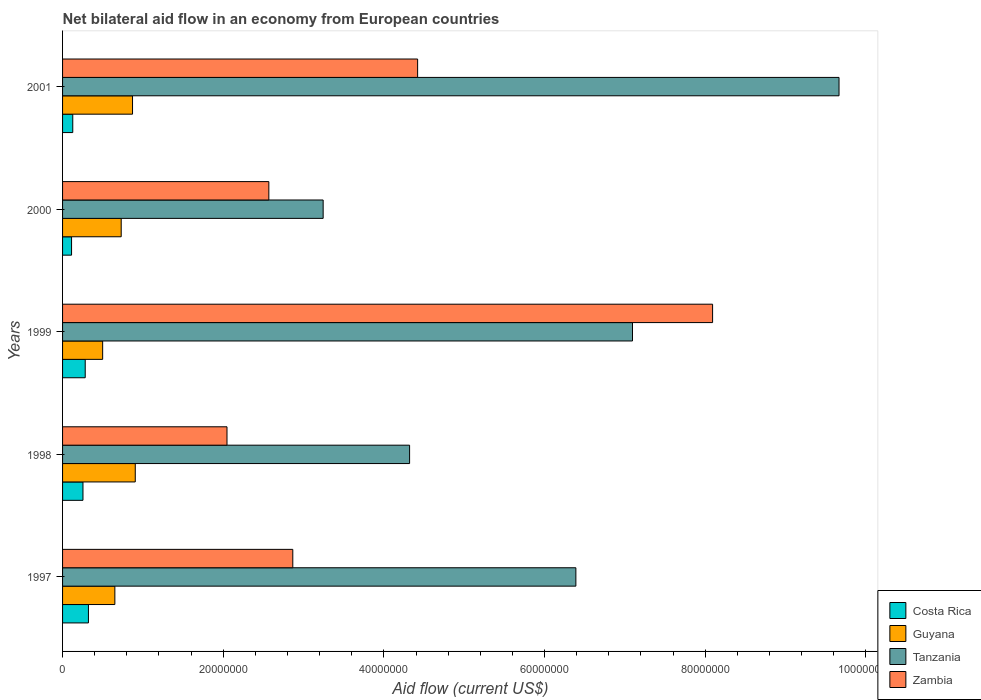How many groups of bars are there?
Offer a terse response. 5. Are the number of bars per tick equal to the number of legend labels?
Provide a short and direct response. Yes. Are the number of bars on each tick of the Y-axis equal?
Keep it short and to the point. Yes. How many bars are there on the 5th tick from the top?
Your answer should be very brief. 4. What is the label of the 1st group of bars from the top?
Provide a short and direct response. 2001. In how many cases, is the number of bars for a given year not equal to the number of legend labels?
Provide a succinct answer. 0. What is the net bilateral aid flow in Costa Rica in 1998?
Provide a short and direct response. 2.54e+06. Across all years, what is the maximum net bilateral aid flow in Guyana?
Give a very brief answer. 9.05e+06. Across all years, what is the minimum net bilateral aid flow in Tanzania?
Give a very brief answer. 3.24e+07. In which year was the net bilateral aid flow in Tanzania maximum?
Offer a very short reply. 2001. In which year was the net bilateral aid flow in Tanzania minimum?
Offer a terse response. 2000. What is the total net bilateral aid flow in Tanzania in the graph?
Keep it short and to the point. 3.07e+08. What is the difference between the net bilateral aid flow in Guyana in 1999 and that in 2000?
Provide a succinct answer. -2.31e+06. What is the difference between the net bilateral aid flow in Zambia in 1998 and the net bilateral aid flow in Costa Rica in 1997?
Your answer should be very brief. 1.72e+07. What is the average net bilateral aid flow in Guyana per year?
Give a very brief answer. 7.31e+06. In the year 2000, what is the difference between the net bilateral aid flow in Zambia and net bilateral aid flow in Costa Rica?
Provide a short and direct response. 2.46e+07. What is the ratio of the net bilateral aid flow in Tanzania in 1999 to that in 2000?
Provide a short and direct response. 2.19. Is the net bilateral aid flow in Zambia in 1999 less than that in 2000?
Ensure brevity in your answer.  No. What is the difference between the highest and the second highest net bilateral aid flow in Costa Rica?
Make the answer very short. 4.00e+05. What is the difference between the highest and the lowest net bilateral aid flow in Tanzania?
Provide a succinct answer. 6.42e+07. Is the sum of the net bilateral aid flow in Tanzania in 1999 and 2001 greater than the maximum net bilateral aid flow in Costa Rica across all years?
Your response must be concise. Yes. Is it the case that in every year, the sum of the net bilateral aid flow in Costa Rica and net bilateral aid flow in Tanzania is greater than the sum of net bilateral aid flow in Guyana and net bilateral aid flow in Zambia?
Provide a succinct answer. Yes. What does the 4th bar from the top in 1998 represents?
Your response must be concise. Costa Rica. What does the 4th bar from the bottom in 2001 represents?
Provide a succinct answer. Zambia. Are all the bars in the graph horizontal?
Ensure brevity in your answer.  Yes. What is the difference between two consecutive major ticks on the X-axis?
Give a very brief answer. 2.00e+07. Does the graph contain any zero values?
Make the answer very short. No. Where does the legend appear in the graph?
Provide a short and direct response. Bottom right. How are the legend labels stacked?
Your response must be concise. Vertical. What is the title of the graph?
Keep it short and to the point. Net bilateral aid flow in an economy from European countries. What is the Aid flow (current US$) in Costa Rica in 1997?
Provide a succinct answer. 3.22e+06. What is the Aid flow (current US$) in Guyana in 1997?
Give a very brief answer. 6.51e+06. What is the Aid flow (current US$) of Tanzania in 1997?
Give a very brief answer. 6.39e+07. What is the Aid flow (current US$) of Zambia in 1997?
Provide a succinct answer. 2.87e+07. What is the Aid flow (current US$) in Costa Rica in 1998?
Your response must be concise. 2.54e+06. What is the Aid flow (current US$) in Guyana in 1998?
Your response must be concise. 9.05e+06. What is the Aid flow (current US$) in Tanzania in 1998?
Give a very brief answer. 4.32e+07. What is the Aid flow (current US$) of Zambia in 1998?
Your answer should be very brief. 2.05e+07. What is the Aid flow (current US$) in Costa Rica in 1999?
Offer a very short reply. 2.82e+06. What is the Aid flow (current US$) of Guyana in 1999?
Provide a succinct answer. 4.99e+06. What is the Aid flow (current US$) in Tanzania in 1999?
Your response must be concise. 7.10e+07. What is the Aid flow (current US$) in Zambia in 1999?
Offer a terse response. 8.09e+07. What is the Aid flow (current US$) in Costa Rica in 2000?
Your answer should be compact. 1.12e+06. What is the Aid flow (current US$) of Guyana in 2000?
Your response must be concise. 7.30e+06. What is the Aid flow (current US$) of Tanzania in 2000?
Offer a terse response. 3.24e+07. What is the Aid flow (current US$) of Zambia in 2000?
Make the answer very short. 2.57e+07. What is the Aid flow (current US$) in Costa Rica in 2001?
Offer a terse response. 1.27e+06. What is the Aid flow (current US$) in Guyana in 2001?
Provide a succinct answer. 8.71e+06. What is the Aid flow (current US$) of Tanzania in 2001?
Offer a terse response. 9.67e+07. What is the Aid flow (current US$) of Zambia in 2001?
Your answer should be very brief. 4.42e+07. Across all years, what is the maximum Aid flow (current US$) in Costa Rica?
Offer a very short reply. 3.22e+06. Across all years, what is the maximum Aid flow (current US$) in Guyana?
Ensure brevity in your answer.  9.05e+06. Across all years, what is the maximum Aid flow (current US$) of Tanzania?
Ensure brevity in your answer.  9.67e+07. Across all years, what is the maximum Aid flow (current US$) in Zambia?
Provide a succinct answer. 8.09e+07. Across all years, what is the minimum Aid flow (current US$) in Costa Rica?
Offer a terse response. 1.12e+06. Across all years, what is the minimum Aid flow (current US$) in Guyana?
Provide a succinct answer. 4.99e+06. Across all years, what is the minimum Aid flow (current US$) of Tanzania?
Provide a succinct answer. 3.24e+07. Across all years, what is the minimum Aid flow (current US$) of Zambia?
Offer a terse response. 2.05e+07. What is the total Aid flow (current US$) in Costa Rica in the graph?
Give a very brief answer. 1.10e+07. What is the total Aid flow (current US$) in Guyana in the graph?
Offer a terse response. 3.66e+07. What is the total Aid flow (current US$) in Tanzania in the graph?
Make the answer very short. 3.07e+08. What is the total Aid flow (current US$) in Zambia in the graph?
Give a very brief answer. 2.00e+08. What is the difference between the Aid flow (current US$) of Costa Rica in 1997 and that in 1998?
Your answer should be compact. 6.80e+05. What is the difference between the Aid flow (current US$) of Guyana in 1997 and that in 1998?
Give a very brief answer. -2.54e+06. What is the difference between the Aid flow (current US$) in Tanzania in 1997 and that in 1998?
Provide a short and direct response. 2.07e+07. What is the difference between the Aid flow (current US$) of Zambia in 1997 and that in 1998?
Your answer should be very brief. 8.19e+06. What is the difference between the Aid flow (current US$) of Guyana in 1997 and that in 1999?
Your answer should be compact. 1.52e+06. What is the difference between the Aid flow (current US$) in Tanzania in 1997 and that in 1999?
Ensure brevity in your answer.  -7.05e+06. What is the difference between the Aid flow (current US$) in Zambia in 1997 and that in 1999?
Make the answer very short. -5.23e+07. What is the difference between the Aid flow (current US$) of Costa Rica in 1997 and that in 2000?
Ensure brevity in your answer.  2.10e+06. What is the difference between the Aid flow (current US$) of Guyana in 1997 and that in 2000?
Keep it short and to the point. -7.90e+05. What is the difference between the Aid flow (current US$) of Tanzania in 1997 and that in 2000?
Offer a terse response. 3.15e+07. What is the difference between the Aid flow (current US$) of Zambia in 1997 and that in 2000?
Make the answer very short. 2.98e+06. What is the difference between the Aid flow (current US$) of Costa Rica in 1997 and that in 2001?
Ensure brevity in your answer.  1.95e+06. What is the difference between the Aid flow (current US$) in Guyana in 1997 and that in 2001?
Your answer should be compact. -2.20e+06. What is the difference between the Aid flow (current US$) of Tanzania in 1997 and that in 2001?
Offer a very short reply. -3.28e+07. What is the difference between the Aid flow (current US$) of Zambia in 1997 and that in 2001?
Your response must be concise. -1.55e+07. What is the difference between the Aid flow (current US$) in Costa Rica in 1998 and that in 1999?
Keep it short and to the point. -2.80e+05. What is the difference between the Aid flow (current US$) of Guyana in 1998 and that in 1999?
Keep it short and to the point. 4.06e+06. What is the difference between the Aid flow (current US$) in Tanzania in 1998 and that in 1999?
Provide a short and direct response. -2.78e+07. What is the difference between the Aid flow (current US$) in Zambia in 1998 and that in 1999?
Make the answer very short. -6.04e+07. What is the difference between the Aid flow (current US$) of Costa Rica in 1998 and that in 2000?
Make the answer very short. 1.42e+06. What is the difference between the Aid flow (current US$) of Guyana in 1998 and that in 2000?
Your answer should be very brief. 1.75e+06. What is the difference between the Aid flow (current US$) of Tanzania in 1998 and that in 2000?
Offer a very short reply. 1.08e+07. What is the difference between the Aid flow (current US$) of Zambia in 1998 and that in 2000?
Ensure brevity in your answer.  -5.21e+06. What is the difference between the Aid flow (current US$) of Costa Rica in 1998 and that in 2001?
Provide a succinct answer. 1.27e+06. What is the difference between the Aid flow (current US$) in Guyana in 1998 and that in 2001?
Offer a very short reply. 3.40e+05. What is the difference between the Aid flow (current US$) in Tanzania in 1998 and that in 2001?
Give a very brief answer. -5.35e+07. What is the difference between the Aid flow (current US$) in Zambia in 1998 and that in 2001?
Your response must be concise. -2.37e+07. What is the difference between the Aid flow (current US$) in Costa Rica in 1999 and that in 2000?
Provide a succinct answer. 1.70e+06. What is the difference between the Aid flow (current US$) of Guyana in 1999 and that in 2000?
Your answer should be compact. -2.31e+06. What is the difference between the Aid flow (current US$) of Tanzania in 1999 and that in 2000?
Your response must be concise. 3.85e+07. What is the difference between the Aid flow (current US$) of Zambia in 1999 and that in 2000?
Your answer should be very brief. 5.52e+07. What is the difference between the Aid flow (current US$) of Costa Rica in 1999 and that in 2001?
Offer a terse response. 1.55e+06. What is the difference between the Aid flow (current US$) in Guyana in 1999 and that in 2001?
Offer a very short reply. -3.72e+06. What is the difference between the Aid flow (current US$) in Tanzania in 1999 and that in 2001?
Your response must be concise. -2.57e+07. What is the difference between the Aid flow (current US$) in Zambia in 1999 and that in 2001?
Provide a short and direct response. 3.67e+07. What is the difference between the Aid flow (current US$) in Costa Rica in 2000 and that in 2001?
Provide a short and direct response. -1.50e+05. What is the difference between the Aid flow (current US$) of Guyana in 2000 and that in 2001?
Give a very brief answer. -1.41e+06. What is the difference between the Aid flow (current US$) in Tanzania in 2000 and that in 2001?
Provide a succinct answer. -6.42e+07. What is the difference between the Aid flow (current US$) in Zambia in 2000 and that in 2001?
Give a very brief answer. -1.85e+07. What is the difference between the Aid flow (current US$) in Costa Rica in 1997 and the Aid flow (current US$) in Guyana in 1998?
Make the answer very short. -5.83e+06. What is the difference between the Aid flow (current US$) in Costa Rica in 1997 and the Aid flow (current US$) in Tanzania in 1998?
Your response must be concise. -4.00e+07. What is the difference between the Aid flow (current US$) in Costa Rica in 1997 and the Aid flow (current US$) in Zambia in 1998?
Your answer should be very brief. -1.72e+07. What is the difference between the Aid flow (current US$) in Guyana in 1997 and the Aid flow (current US$) in Tanzania in 1998?
Ensure brevity in your answer.  -3.67e+07. What is the difference between the Aid flow (current US$) in Guyana in 1997 and the Aid flow (current US$) in Zambia in 1998?
Make the answer very short. -1.40e+07. What is the difference between the Aid flow (current US$) of Tanzania in 1997 and the Aid flow (current US$) of Zambia in 1998?
Your response must be concise. 4.34e+07. What is the difference between the Aid flow (current US$) in Costa Rica in 1997 and the Aid flow (current US$) in Guyana in 1999?
Provide a short and direct response. -1.77e+06. What is the difference between the Aid flow (current US$) of Costa Rica in 1997 and the Aid flow (current US$) of Tanzania in 1999?
Make the answer very short. -6.77e+07. What is the difference between the Aid flow (current US$) in Costa Rica in 1997 and the Aid flow (current US$) in Zambia in 1999?
Your response must be concise. -7.77e+07. What is the difference between the Aid flow (current US$) in Guyana in 1997 and the Aid flow (current US$) in Tanzania in 1999?
Offer a terse response. -6.44e+07. What is the difference between the Aid flow (current US$) of Guyana in 1997 and the Aid flow (current US$) of Zambia in 1999?
Offer a terse response. -7.44e+07. What is the difference between the Aid flow (current US$) in Tanzania in 1997 and the Aid flow (current US$) in Zambia in 1999?
Provide a succinct answer. -1.70e+07. What is the difference between the Aid flow (current US$) in Costa Rica in 1997 and the Aid flow (current US$) in Guyana in 2000?
Your answer should be very brief. -4.08e+06. What is the difference between the Aid flow (current US$) in Costa Rica in 1997 and the Aid flow (current US$) in Tanzania in 2000?
Your response must be concise. -2.92e+07. What is the difference between the Aid flow (current US$) of Costa Rica in 1997 and the Aid flow (current US$) of Zambia in 2000?
Offer a very short reply. -2.25e+07. What is the difference between the Aid flow (current US$) in Guyana in 1997 and the Aid flow (current US$) in Tanzania in 2000?
Offer a very short reply. -2.59e+07. What is the difference between the Aid flow (current US$) in Guyana in 1997 and the Aid flow (current US$) in Zambia in 2000?
Keep it short and to the point. -1.92e+07. What is the difference between the Aid flow (current US$) of Tanzania in 1997 and the Aid flow (current US$) of Zambia in 2000?
Ensure brevity in your answer.  3.82e+07. What is the difference between the Aid flow (current US$) in Costa Rica in 1997 and the Aid flow (current US$) in Guyana in 2001?
Offer a very short reply. -5.49e+06. What is the difference between the Aid flow (current US$) in Costa Rica in 1997 and the Aid flow (current US$) in Tanzania in 2001?
Give a very brief answer. -9.34e+07. What is the difference between the Aid flow (current US$) of Costa Rica in 1997 and the Aid flow (current US$) of Zambia in 2001?
Provide a succinct answer. -4.10e+07. What is the difference between the Aid flow (current US$) in Guyana in 1997 and the Aid flow (current US$) in Tanzania in 2001?
Keep it short and to the point. -9.02e+07. What is the difference between the Aid flow (current US$) of Guyana in 1997 and the Aid flow (current US$) of Zambia in 2001?
Your response must be concise. -3.77e+07. What is the difference between the Aid flow (current US$) in Tanzania in 1997 and the Aid flow (current US$) in Zambia in 2001?
Your answer should be compact. 1.97e+07. What is the difference between the Aid flow (current US$) of Costa Rica in 1998 and the Aid flow (current US$) of Guyana in 1999?
Provide a succinct answer. -2.45e+06. What is the difference between the Aid flow (current US$) in Costa Rica in 1998 and the Aid flow (current US$) in Tanzania in 1999?
Provide a succinct answer. -6.84e+07. What is the difference between the Aid flow (current US$) of Costa Rica in 1998 and the Aid flow (current US$) of Zambia in 1999?
Make the answer very short. -7.84e+07. What is the difference between the Aid flow (current US$) in Guyana in 1998 and the Aid flow (current US$) in Tanzania in 1999?
Give a very brief answer. -6.19e+07. What is the difference between the Aid flow (current US$) of Guyana in 1998 and the Aid flow (current US$) of Zambia in 1999?
Make the answer very short. -7.19e+07. What is the difference between the Aid flow (current US$) in Tanzania in 1998 and the Aid flow (current US$) in Zambia in 1999?
Your answer should be very brief. -3.77e+07. What is the difference between the Aid flow (current US$) in Costa Rica in 1998 and the Aid flow (current US$) in Guyana in 2000?
Offer a very short reply. -4.76e+06. What is the difference between the Aid flow (current US$) of Costa Rica in 1998 and the Aid flow (current US$) of Tanzania in 2000?
Provide a succinct answer. -2.99e+07. What is the difference between the Aid flow (current US$) in Costa Rica in 1998 and the Aid flow (current US$) in Zambia in 2000?
Your answer should be compact. -2.31e+07. What is the difference between the Aid flow (current US$) in Guyana in 1998 and the Aid flow (current US$) in Tanzania in 2000?
Your response must be concise. -2.34e+07. What is the difference between the Aid flow (current US$) of Guyana in 1998 and the Aid flow (current US$) of Zambia in 2000?
Offer a very short reply. -1.66e+07. What is the difference between the Aid flow (current US$) in Tanzania in 1998 and the Aid flow (current US$) in Zambia in 2000?
Provide a succinct answer. 1.75e+07. What is the difference between the Aid flow (current US$) of Costa Rica in 1998 and the Aid flow (current US$) of Guyana in 2001?
Your answer should be very brief. -6.17e+06. What is the difference between the Aid flow (current US$) of Costa Rica in 1998 and the Aid flow (current US$) of Tanzania in 2001?
Offer a terse response. -9.41e+07. What is the difference between the Aid flow (current US$) in Costa Rica in 1998 and the Aid flow (current US$) in Zambia in 2001?
Your answer should be very brief. -4.17e+07. What is the difference between the Aid flow (current US$) in Guyana in 1998 and the Aid flow (current US$) in Tanzania in 2001?
Give a very brief answer. -8.76e+07. What is the difference between the Aid flow (current US$) in Guyana in 1998 and the Aid flow (current US$) in Zambia in 2001?
Offer a terse response. -3.52e+07. What is the difference between the Aid flow (current US$) of Tanzania in 1998 and the Aid flow (current US$) of Zambia in 2001?
Provide a succinct answer. -1.00e+06. What is the difference between the Aid flow (current US$) of Costa Rica in 1999 and the Aid flow (current US$) of Guyana in 2000?
Keep it short and to the point. -4.48e+06. What is the difference between the Aid flow (current US$) of Costa Rica in 1999 and the Aid flow (current US$) of Tanzania in 2000?
Ensure brevity in your answer.  -2.96e+07. What is the difference between the Aid flow (current US$) in Costa Rica in 1999 and the Aid flow (current US$) in Zambia in 2000?
Provide a succinct answer. -2.29e+07. What is the difference between the Aid flow (current US$) in Guyana in 1999 and the Aid flow (current US$) in Tanzania in 2000?
Make the answer very short. -2.74e+07. What is the difference between the Aid flow (current US$) in Guyana in 1999 and the Aid flow (current US$) in Zambia in 2000?
Offer a terse response. -2.07e+07. What is the difference between the Aid flow (current US$) of Tanzania in 1999 and the Aid flow (current US$) of Zambia in 2000?
Offer a terse response. 4.53e+07. What is the difference between the Aid flow (current US$) of Costa Rica in 1999 and the Aid flow (current US$) of Guyana in 2001?
Your answer should be compact. -5.89e+06. What is the difference between the Aid flow (current US$) of Costa Rica in 1999 and the Aid flow (current US$) of Tanzania in 2001?
Offer a terse response. -9.38e+07. What is the difference between the Aid flow (current US$) of Costa Rica in 1999 and the Aid flow (current US$) of Zambia in 2001?
Offer a terse response. -4.14e+07. What is the difference between the Aid flow (current US$) of Guyana in 1999 and the Aid flow (current US$) of Tanzania in 2001?
Provide a short and direct response. -9.17e+07. What is the difference between the Aid flow (current US$) in Guyana in 1999 and the Aid flow (current US$) in Zambia in 2001?
Ensure brevity in your answer.  -3.92e+07. What is the difference between the Aid flow (current US$) of Tanzania in 1999 and the Aid flow (current US$) of Zambia in 2001?
Provide a succinct answer. 2.68e+07. What is the difference between the Aid flow (current US$) of Costa Rica in 2000 and the Aid flow (current US$) of Guyana in 2001?
Provide a succinct answer. -7.59e+06. What is the difference between the Aid flow (current US$) of Costa Rica in 2000 and the Aid flow (current US$) of Tanzania in 2001?
Provide a succinct answer. -9.55e+07. What is the difference between the Aid flow (current US$) in Costa Rica in 2000 and the Aid flow (current US$) in Zambia in 2001?
Your response must be concise. -4.31e+07. What is the difference between the Aid flow (current US$) of Guyana in 2000 and the Aid flow (current US$) of Tanzania in 2001?
Provide a succinct answer. -8.94e+07. What is the difference between the Aid flow (current US$) of Guyana in 2000 and the Aid flow (current US$) of Zambia in 2001?
Provide a short and direct response. -3.69e+07. What is the difference between the Aid flow (current US$) of Tanzania in 2000 and the Aid flow (current US$) of Zambia in 2001?
Your response must be concise. -1.18e+07. What is the average Aid flow (current US$) in Costa Rica per year?
Your answer should be compact. 2.19e+06. What is the average Aid flow (current US$) of Guyana per year?
Ensure brevity in your answer.  7.31e+06. What is the average Aid flow (current US$) in Tanzania per year?
Ensure brevity in your answer.  6.14e+07. What is the average Aid flow (current US$) in Zambia per year?
Ensure brevity in your answer.  4.00e+07. In the year 1997, what is the difference between the Aid flow (current US$) in Costa Rica and Aid flow (current US$) in Guyana?
Keep it short and to the point. -3.29e+06. In the year 1997, what is the difference between the Aid flow (current US$) in Costa Rica and Aid flow (current US$) in Tanzania?
Give a very brief answer. -6.07e+07. In the year 1997, what is the difference between the Aid flow (current US$) in Costa Rica and Aid flow (current US$) in Zambia?
Offer a terse response. -2.54e+07. In the year 1997, what is the difference between the Aid flow (current US$) of Guyana and Aid flow (current US$) of Tanzania?
Your answer should be very brief. -5.74e+07. In the year 1997, what is the difference between the Aid flow (current US$) in Guyana and Aid flow (current US$) in Zambia?
Your answer should be very brief. -2.22e+07. In the year 1997, what is the difference between the Aid flow (current US$) in Tanzania and Aid flow (current US$) in Zambia?
Your response must be concise. 3.52e+07. In the year 1998, what is the difference between the Aid flow (current US$) of Costa Rica and Aid flow (current US$) of Guyana?
Ensure brevity in your answer.  -6.51e+06. In the year 1998, what is the difference between the Aid flow (current US$) in Costa Rica and Aid flow (current US$) in Tanzania?
Offer a very short reply. -4.07e+07. In the year 1998, what is the difference between the Aid flow (current US$) of Costa Rica and Aid flow (current US$) of Zambia?
Ensure brevity in your answer.  -1.79e+07. In the year 1998, what is the difference between the Aid flow (current US$) of Guyana and Aid flow (current US$) of Tanzania?
Your answer should be compact. -3.42e+07. In the year 1998, what is the difference between the Aid flow (current US$) of Guyana and Aid flow (current US$) of Zambia?
Provide a succinct answer. -1.14e+07. In the year 1998, what is the difference between the Aid flow (current US$) of Tanzania and Aid flow (current US$) of Zambia?
Offer a very short reply. 2.27e+07. In the year 1999, what is the difference between the Aid flow (current US$) of Costa Rica and Aid flow (current US$) of Guyana?
Give a very brief answer. -2.17e+06. In the year 1999, what is the difference between the Aid flow (current US$) of Costa Rica and Aid flow (current US$) of Tanzania?
Provide a short and direct response. -6.81e+07. In the year 1999, what is the difference between the Aid flow (current US$) of Costa Rica and Aid flow (current US$) of Zambia?
Ensure brevity in your answer.  -7.81e+07. In the year 1999, what is the difference between the Aid flow (current US$) of Guyana and Aid flow (current US$) of Tanzania?
Make the answer very short. -6.60e+07. In the year 1999, what is the difference between the Aid flow (current US$) in Guyana and Aid flow (current US$) in Zambia?
Your answer should be compact. -7.59e+07. In the year 1999, what is the difference between the Aid flow (current US$) in Tanzania and Aid flow (current US$) in Zambia?
Ensure brevity in your answer.  -9.97e+06. In the year 2000, what is the difference between the Aid flow (current US$) of Costa Rica and Aid flow (current US$) of Guyana?
Keep it short and to the point. -6.18e+06. In the year 2000, what is the difference between the Aid flow (current US$) of Costa Rica and Aid flow (current US$) of Tanzania?
Provide a succinct answer. -3.13e+07. In the year 2000, what is the difference between the Aid flow (current US$) of Costa Rica and Aid flow (current US$) of Zambia?
Your answer should be very brief. -2.46e+07. In the year 2000, what is the difference between the Aid flow (current US$) of Guyana and Aid flow (current US$) of Tanzania?
Keep it short and to the point. -2.51e+07. In the year 2000, what is the difference between the Aid flow (current US$) of Guyana and Aid flow (current US$) of Zambia?
Make the answer very short. -1.84e+07. In the year 2000, what is the difference between the Aid flow (current US$) of Tanzania and Aid flow (current US$) of Zambia?
Ensure brevity in your answer.  6.76e+06. In the year 2001, what is the difference between the Aid flow (current US$) in Costa Rica and Aid flow (current US$) in Guyana?
Make the answer very short. -7.44e+06. In the year 2001, what is the difference between the Aid flow (current US$) in Costa Rica and Aid flow (current US$) in Tanzania?
Provide a short and direct response. -9.54e+07. In the year 2001, what is the difference between the Aid flow (current US$) in Costa Rica and Aid flow (current US$) in Zambia?
Your response must be concise. -4.29e+07. In the year 2001, what is the difference between the Aid flow (current US$) of Guyana and Aid flow (current US$) of Tanzania?
Give a very brief answer. -8.80e+07. In the year 2001, what is the difference between the Aid flow (current US$) of Guyana and Aid flow (current US$) of Zambia?
Your response must be concise. -3.55e+07. In the year 2001, what is the difference between the Aid flow (current US$) of Tanzania and Aid flow (current US$) of Zambia?
Provide a succinct answer. 5.25e+07. What is the ratio of the Aid flow (current US$) in Costa Rica in 1997 to that in 1998?
Offer a terse response. 1.27. What is the ratio of the Aid flow (current US$) in Guyana in 1997 to that in 1998?
Ensure brevity in your answer.  0.72. What is the ratio of the Aid flow (current US$) in Tanzania in 1997 to that in 1998?
Make the answer very short. 1.48. What is the ratio of the Aid flow (current US$) in Zambia in 1997 to that in 1998?
Offer a terse response. 1.4. What is the ratio of the Aid flow (current US$) of Costa Rica in 1997 to that in 1999?
Ensure brevity in your answer.  1.14. What is the ratio of the Aid flow (current US$) in Guyana in 1997 to that in 1999?
Provide a succinct answer. 1.3. What is the ratio of the Aid flow (current US$) of Tanzania in 1997 to that in 1999?
Offer a very short reply. 0.9. What is the ratio of the Aid flow (current US$) of Zambia in 1997 to that in 1999?
Make the answer very short. 0.35. What is the ratio of the Aid flow (current US$) of Costa Rica in 1997 to that in 2000?
Offer a terse response. 2.88. What is the ratio of the Aid flow (current US$) in Guyana in 1997 to that in 2000?
Your response must be concise. 0.89. What is the ratio of the Aid flow (current US$) in Tanzania in 1997 to that in 2000?
Ensure brevity in your answer.  1.97. What is the ratio of the Aid flow (current US$) of Zambia in 1997 to that in 2000?
Offer a very short reply. 1.12. What is the ratio of the Aid flow (current US$) in Costa Rica in 1997 to that in 2001?
Give a very brief answer. 2.54. What is the ratio of the Aid flow (current US$) of Guyana in 1997 to that in 2001?
Offer a terse response. 0.75. What is the ratio of the Aid flow (current US$) of Tanzania in 1997 to that in 2001?
Keep it short and to the point. 0.66. What is the ratio of the Aid flow (current US$) of Zambia in 1997 to that in 2001?
Offer a very short reply. 0.65. What is the ratio of the Aid flow (current US$) of Costa Rica in 1998 to that in 1999?
Give a very brief answer. 0.9. What is the ratio of the Aid flow (current US$) in Guyana in 1998 to that in 1999?
Provide a succinct answer. 1.81. What is the ratio of the Aid flow (current US$) of Tanzania in 1998 to that in 1999?
Ensure brevity in your answer.  0.61. What is the ratio of the Aid flow (current US$) of Zambia in 1998 to that in 1999?
Make the answer very short. 0.25. What is the ratio of the Aid flow (current US$) in Costa Rica in 1998 to that in 2000?
Ensure brevity in your answer.  2.27. What is the ratio of the Aid flow (current US$) of Guyana in 1998 to that in 2000?
Offer a very short reply. 1.24. What is the ratio of the Aid flow (current US$) of Tanzania in 1998 to that in 2000?
Your answer should be compact. 1.33. What is the ratio of the Aid flow (current US$) in Zambia in 1998 to that in 2000?
Your response must be concise. 0.8. What is the ratio of the Aid flow (current US$) of Costa Rica in 1998 to that in 2001?
Ensure brevity in your answer.  2. What is the ratio of the Aid flow (current US$) in Guyana in 1998 to that in 2001?
Your response must be concise. 1.04. What is the ratio of the Aid flow (current US$) in Tanzania in 1998 to that in 2001?
Offer a very short reply. 0.45. What is the ratio of the Aid flow (current US$) of Zambia in 1998 to that in 2001?
Provide a short and direct response. 0.46. What is the ratio of the Aid flow (current US$) of Costa Rica in 1999 to that in 2000?
Provide a succinct answer. 2.52. What is the ratio of the Aid flow (current US$) of Guyana in 1999 to that in 2000?
Your response must be concise. 0.68. What is the ratio of the Aid flow (current US$) in Tanzania in 1999 to that in 2000?
Offer a very short reply. 2.19. What is the ratio of the Aid flow (current US$) in Zambia in 1999 to that in 2000?
Provide a short and direct response. 3.15. What is the ratio of the Aid flow (current US$) of Costa Rica in 1999 to that in 2001?
Make the answer very short. 2.22. What is the ratio of the Aid flow (current US$) in Guyana in 1999 to that in 2001?
Keep it short and to the point. 0.57. What is the ratio of the Aid flow (current US$) of Tanzania in 1999 to that in 2001?
Offer a terse response. 0.73. What is the ratio of the Aid flow (current US$) in Zambia in 1999 to that in 2001?
Provide a short and direct response. 1.83. What is the ratio of the Aid flow (current US$) in Costa Rica in 2000 to that in 2001?
Give a very brief answer. 0.88. What is the ratio of the Aid flow (current US$) of Guyana in 2000 to that in 2001?
Your response must be concise. 0.84. What is the ratio of the Aid flow (current US$) in Tanzania in 2000 to that in 2001?
Provide a short and direct response. 0.34. What is the ratio of the Aid flow (current US$) of Zambia in 2000 to that in 2001?
Offer a very short reply. 0.58. What is the difference between the highest and the second highest Aid flow (current US$) in Guyana?
Provide a short and direct response. 3.40e+05. What is the difference between the highest and the second highest Aid flow (current US$) of Tanzania?
Provide a short and direct response. 2.57e+07. What is the difference between the highest and the second highest Aid flow (current US$) in Zambia?
Your response must be concise. 3.67e+07. What is the difference between the highest and the lowest Aid flow (current US$) in Costa Rica?
Ensure brevity in your answer.  2.10e+06. What is the difference between the highest and the lowest Aid flow (current US$) of Guyana?
Provide a succinct answer. 4.06e+06. What is the difference between the highest and the lowest Aid flow (current US$) in Tanzania?
Keep it short and to the point. 6.42e+07. What is the difference between the highest and the lowest Aid flow (current US$) of Zambia?
Ensure brevity in your answer.  6.04e+07. 